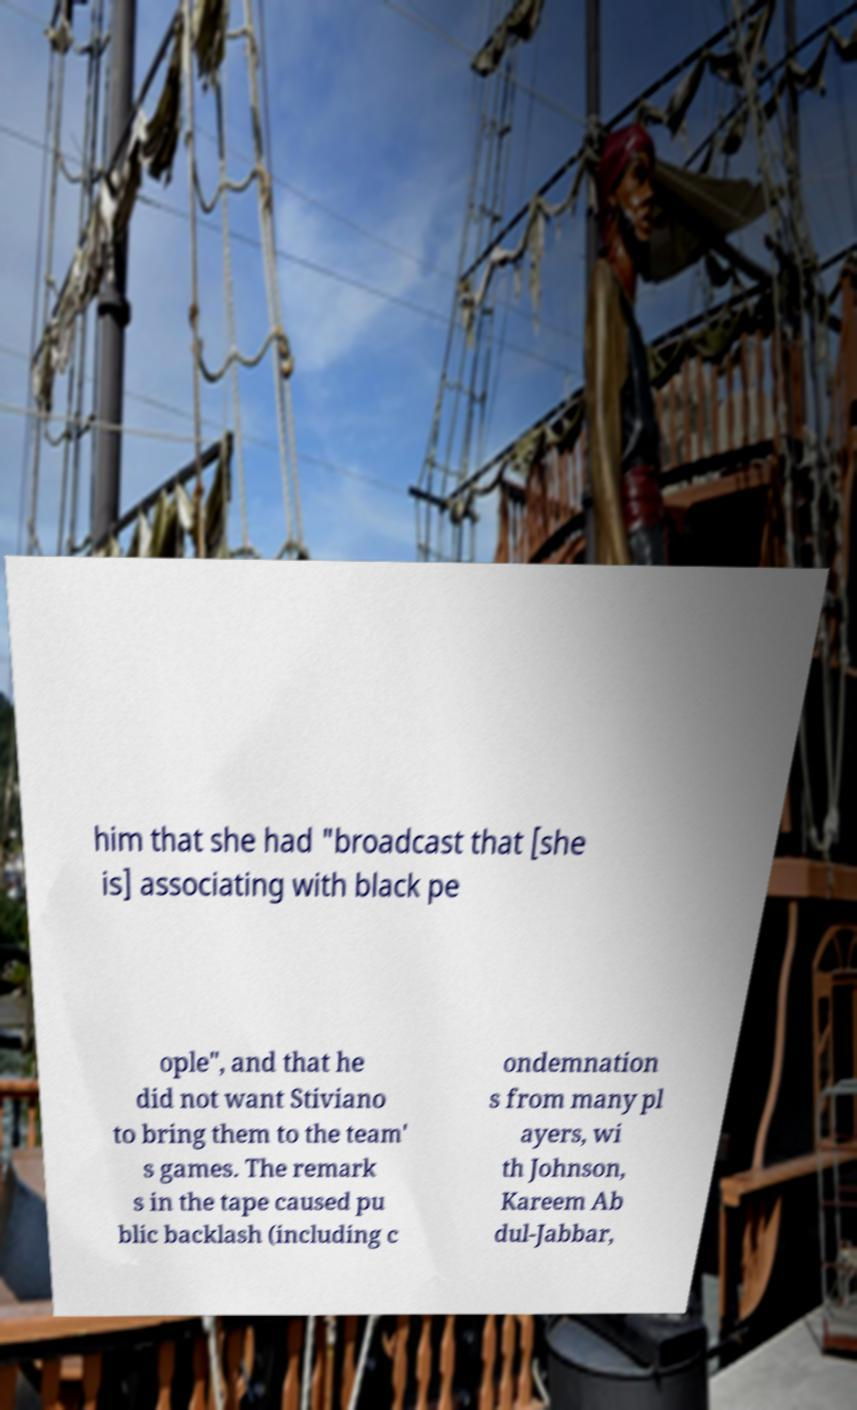What messages or text are displayed in this image? I need them in a readable, typed format. him that she had "broadcast that [she is] associating with black pe ople", and that he did not want Stiviano to bring them to the team' s games. The remark s in the tape caused pu blic backlash (including c ondemnation s from many pl ayers, wi th Johnson, Kareem Ab dul-Jabbar, 